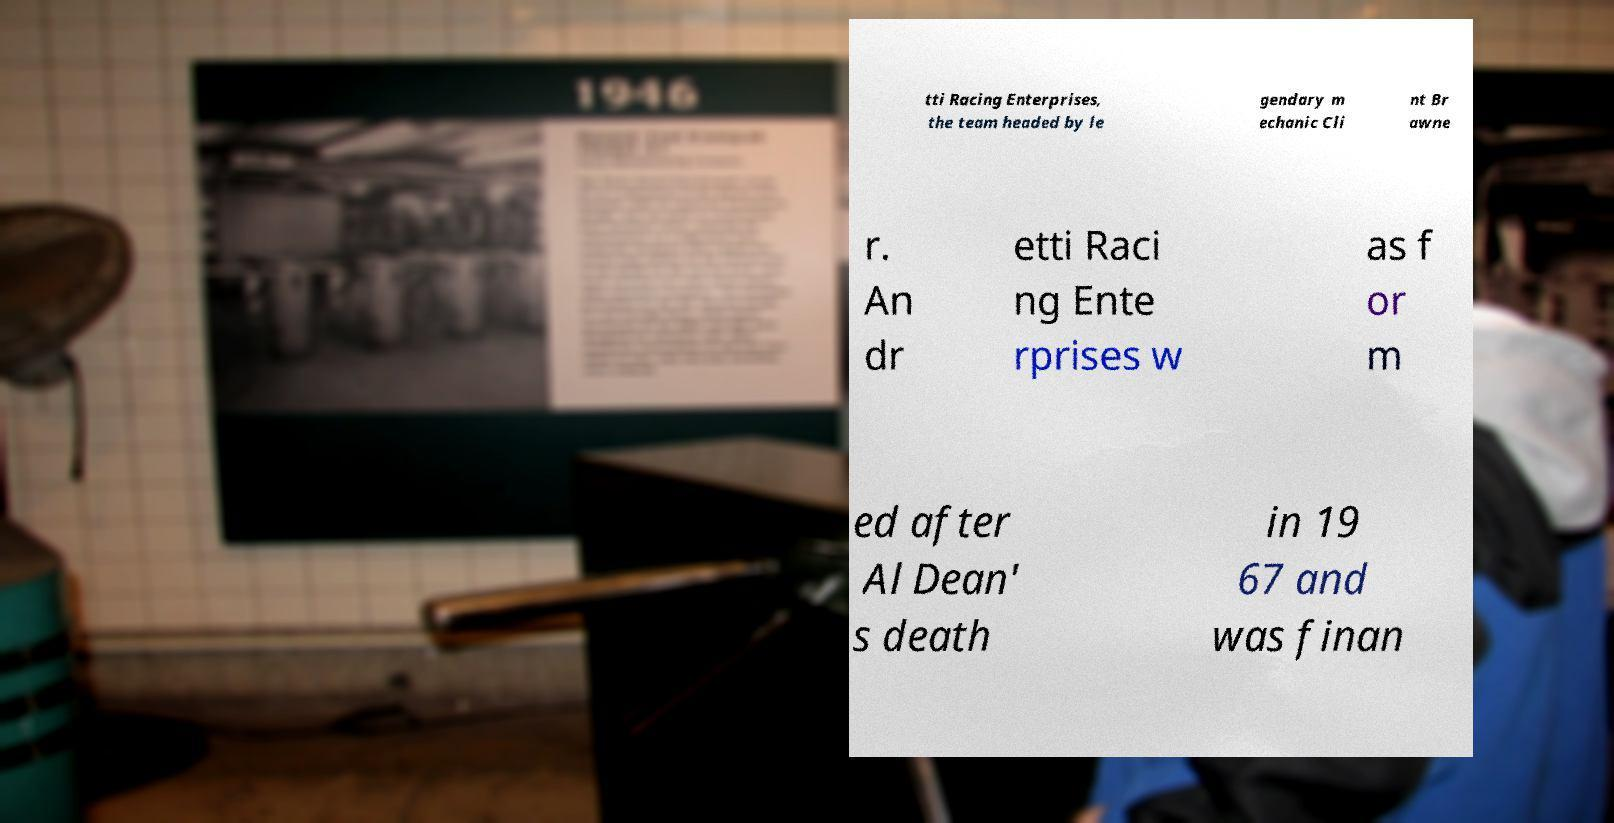What messages or text are displayed in this image? I need them in a readable, typed format. tti Racing Enterprises, the team headed by le gendary m echanic Cli nt Br awne r. An dr etti Raci ng Ente rprises w as f or m ed after Al Dean' s death in 19 67 and was finan 